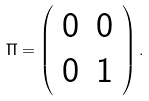Convert formula to latex. <formula><loc_0><loc_0><loc_500><loc_500>\Pi = \left ( \begin{array} { c c } 0 & 0 \\ 0 & 1 \end{array} \right ) .</formula> 